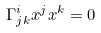Convert formula to latex. <formula><loc_0><loc_0><loc_500><loc_500>\Gamma ^ { i } _ { j k } x ^ { j } x ^ { k } = 0</formula> 